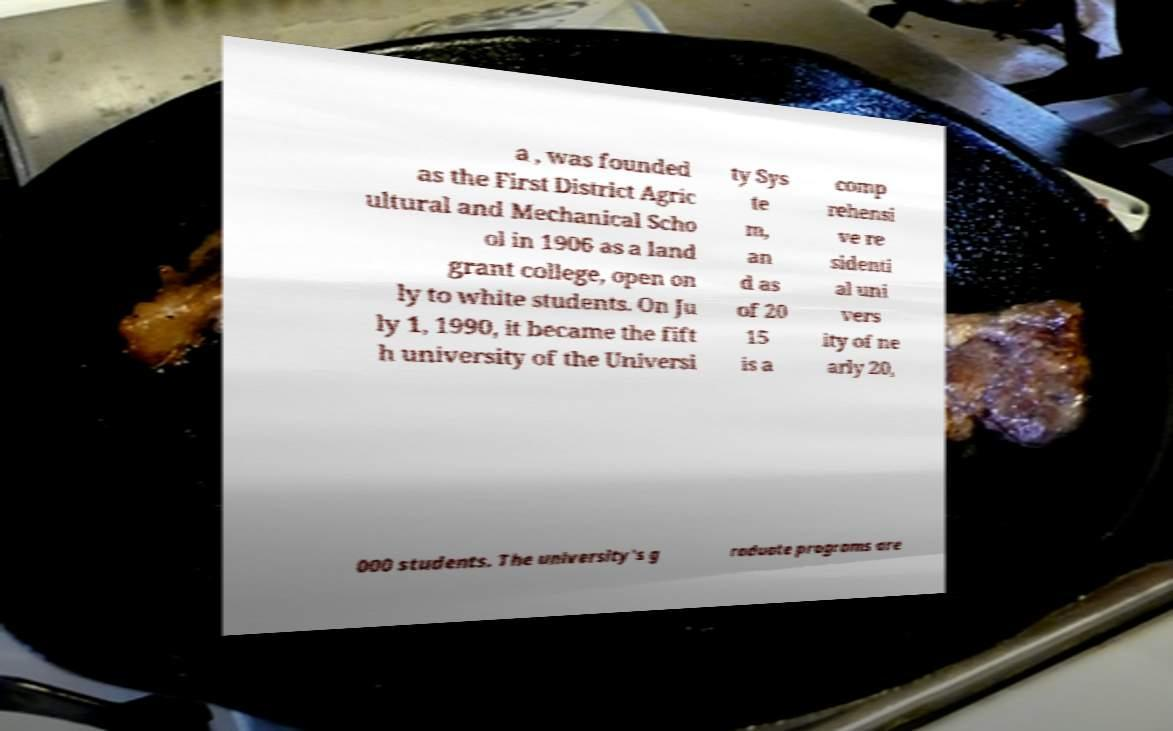Can you read and provide the text displayed in the image?This photo seems to have some interesting text. Can you extract and type it out for me? a , was founded as the First District Agric ultural and Mechanical Scho ol in 1906 as a land grant college, open on ly to white students. On Ju ly 1, 1990, it became the fift h university of the Universi ty Sys te m, an d as of 20 15 is a comp rehensi ve re sidenti al uni vers ity of ne arly 20, 000 students. The university's g raduate programs are 